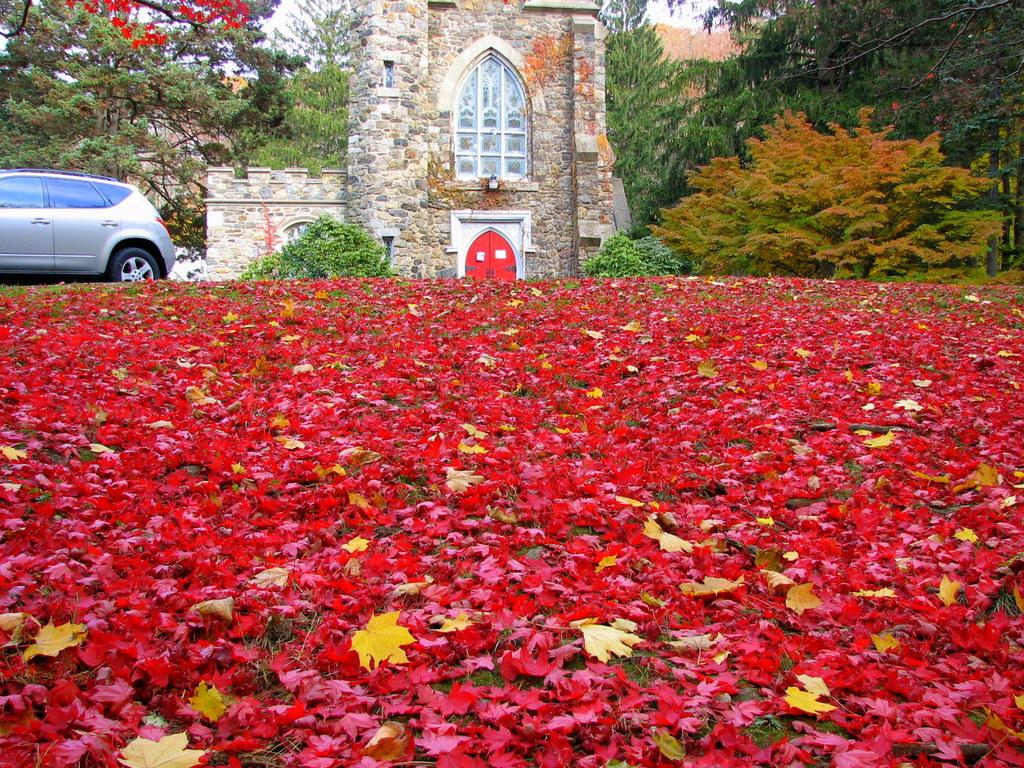What is covering the ground in the image? There are many leaves on the ground in the image. What can be seen on the left side of the image? There is a vehicle on the left side of the image. What structure is located in the middle of the image? There is a house in the middle of the image. What type of vegetation is visible at the back of the image? There are many trees visible at the back of the image. What type of furniture is being exchanged between the trees in the image? There is no furniture present in the image, nor is there any exchange taking place between the trees. 